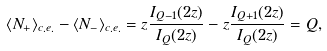Convert formula to latex. <formula><loc_0><loc_0><loc_500><loc_500>\langle N _ { + } \rangle _ { c . e . } - \langle N _ { - } \rangle _ { c . e . } = z \frac { I _ { Q - 1 } ( 2 z ) } { I _ { Q } ( 2 z ) } - z \frac { I _ { Q + 1 } ( 2 z ) } { I _ { Q } ( 2 z ) } = Q ,</formula> 